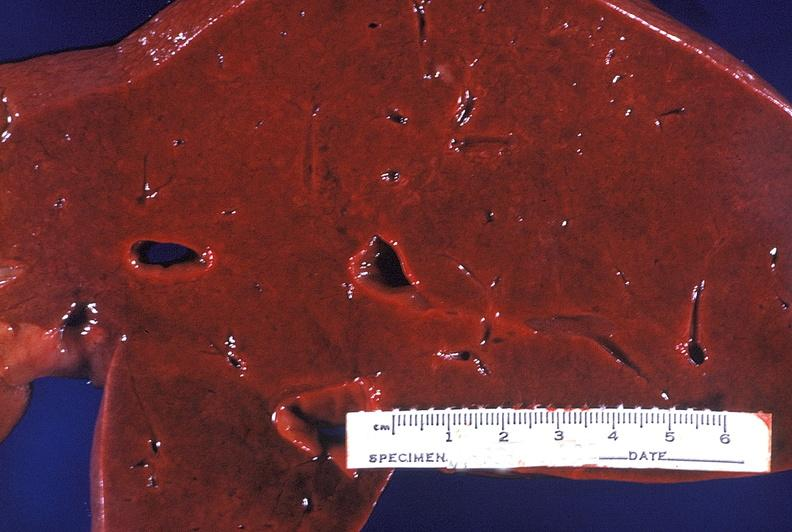does this image show normal liver?
Answer the question using a single word or phrase. Yes 